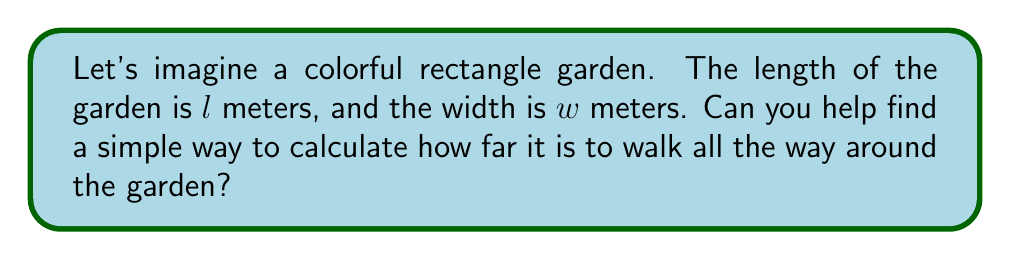Teach me how to tackle this problem. Great question! Let's break this down into easy steps:

1. First, we need to understand what "all the way around" means. This is called the perimeter of the rectangle.

2. To walk around the garden, we need to go along each side:
   - We walk along the length once: $l$
   - Then we walk along the width: $w$
   - Then we walk along the other length: $l$ again
   - Finally, we walk along the other width: $w$ again

3. So, to get the total distance, we add all these sides together:
   $$\text{Perimeter} = l + w + l + w$$

4. We can simplify this by combining the same sides:
   $$\text{Perimeter} = 2l + 2w$$

5. This gives us a simple formula for the perimeter of a rectangle:
   $$\text{Perimeter} = 2(l + w)$$

This formula works for any rectangle, no matter how big or small it is!
Answer: The perimeter of a rectangle can be calculated using the formula:

$$\text{Perimeter} = 2(l + w)$$

where $l$ is the length and $w$ is the width of the rectangle. 